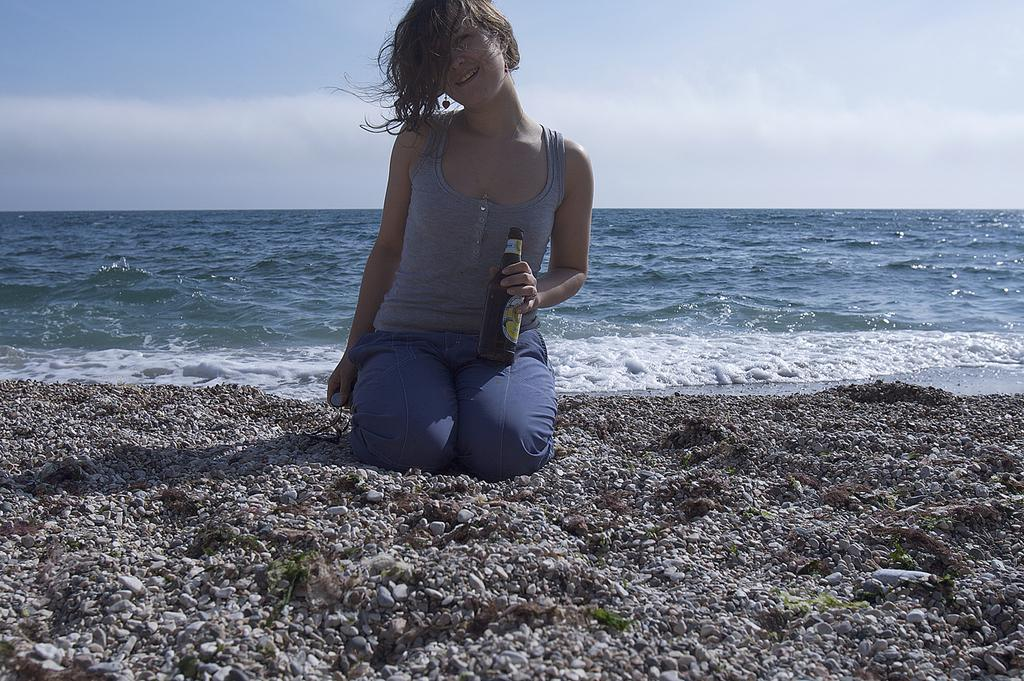Who is in the image? There is a woman in the image. What is the woman holding in the image? The woman is holding a bottle. What is the woman's position in the image? The woman is kneeled down on the sand. What type of terrain is visible in the image? Rocks are present in the sand. What can be seen in the background of the image? There is a sea visible behind the woman. What type of doll is sitting on the edge of the sea in the image? There is no doll present in the image; it only features a woman holding a bottle and kneeled down on the sand. 